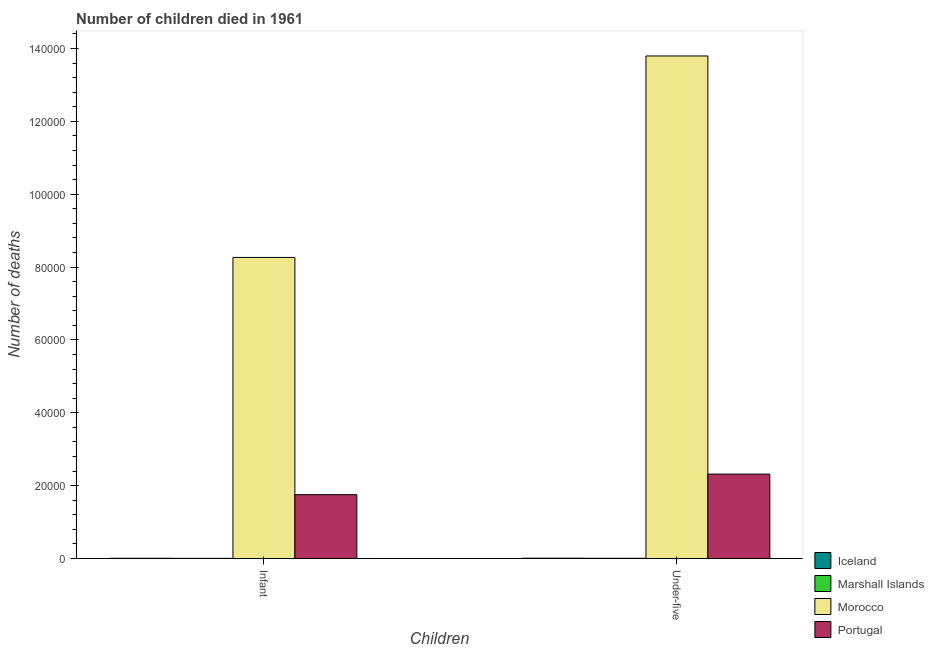How many different coloured bars are there?
Ensure brevity in your answer.  4. How many bars are there on the 2nd tick from the left?
Make the answer very short. 4. How many bars are there on the 2nd tick from the right?
Provide a short and direct response. 4. What is the label of the 2nd group of bars from the left?
Provide a succinct answer. Under-five. What is the number of under-five deaths in Morocco?
Your answer should be very brief. 1.38e+05. Across all countries, what is the maximum number of under-five deaths?
Make the answer very short. 1.38e+05. Across all countries, what is the minimum number of under-five deaths?
Keep it short and to the point. 79. In which country was the number of infant deaths maximum?
Your response must be concise. Morocco. In which country was the number of under-five deaths minimum?
Your response must be concise. Marshall Islands. What is the total number of under-five deaths in the graph?
Make the answer very short. 1.61e+05. What is the difference between the number of under-five deaths in Marshall Islands and that in Morocco?
Provide a succinct answer. -1.38e+05. What is the difference between the number of under-five deaths in Marshall Islands and the number of infant deaths in Iceland?
Your answer should be compact. -6. What is the average number of infant deaths per country?
Ensure brevity in your answer.  2.51e+04. What is the difference between the number of infant deaths and number of under-five deaths in Marshall Islands?
Your answer should be very brief. -23. In how many countries, is the number of infant deaths greater than 76000 ?
Your answer should be very brief. 1. What is the ratio of the number of under-five deaths in Morocco to that in Portugal?
Your answer should be very brief. 5.95. Is the number of infant deaths in Portugal less than that in Iceland?
Your response must be concise. No. In how many countries, is the number of infant deaths greater than the average number of infant deaths taken over all countries?
Keep it short and to the point. 1. What does the 3rd bar from the left in Infant represents?
Give a very brief answer. Morocco. How many countries are there in the graph?
Give a very brief answer. 4. What is the difference between two consecutive major ticks on the Y-axis?
Offer a terse response. 2.00e+04. Are the values on the major ticks of Y-axis written in scientific E-notation?
Make the answer very short. No. Does the graph contain any zero values?
Your answer should be very brief. No. Does the graph contain grids?
Your answer should be compact. No. Where does the legend appear in the graph?
Provide a succinct answer. Bottom right. What is the title of the graph?
Your answer should be very brief. Number of children died in 1961. What is the label or title of the X-axis?
Your answer should be very brief. Children. What is the label or title of the Y-axis?
Provide a succinct answer. Number of deaths. What is the Number of deaths of Iceland in Infant?
Your answer should be very brief. 85. What is the Number of deaths of Morocco in Infant?
Offer a very short reply. 8.27e+04. What is the Number of deaths of Portugal in Infant?
Offer a very short reply. 1.75e+04. What is the Number of deaths of Iceland in Under-five?
Your response must be concise. 104. What is the Number of deaths in Marshall Islands in Under-five?
Provide a short and direct response. 79. What is the Number of deaths of Morocco in Under-five?
Offer a terse response. 1.38e+05. What is the Number of deaths in Portugal in Under-five?
Provide a succinct answer. 2.32e+04. Across all Children, what is the maximum Number of deaths in Iceland?
Give a very brief answer. 104. Across all Children, what is the maximum Number of deaths of Marshall Islands?
Provide a succinct answer. 79. Across all Children, what is the maximum Number of deaths of Morocco?
Give a very brief answer. 1.38e+05. Across all Children, what is the maximum Number of deaths in Portugal?
Ensure brevity in your answer.  2.32e+04. Across all Children, what is the minimum Number of deaths of Iceland?
Keep it short and to the point. 85. Across all Children, what is the minimum Number of deaths in Marshall Islands?
Provide a succinct answer. 56. Across all Children, what is the minimum Number of deaths of Morocco?
Keep it short and to the point. 8.27e+04. Across all Children, what is the minimum Number of deaths in Portugal?
Keep it short and to the point. 1.75e+04. What is the total Number of deaths of Iceland in the graph?
Ensure brevity in your answer.  189. What is the total Number of deaths in Marshall Islands in the graph?
Your response must be concise. 135. What is the total Number of deaths of Morocco in the graph?
Offer a very short reply. 2.21e+05. What is the total Number of deaths in Portugal in the graph?
Offer a terse response. 4.07e+04. What is the difference between the Number of deaths of Iceland in Infant and that in Under-five?
Your answer should be compact. -19. What is the difference between the Number of deaths in Morocco in Infant and that in Under-five?
Keep it short and to the point. -5.53e+04. What is the difference between the Number of deaths of Portugal in Infant and that in Under-five?
Make the answer very short. -5643. What is the difference between the Number of deaths in Iceland in Infant and the Number of deaths in Morocco in Under-five?
Provide a succinct answer. -1.38e+05. What is the difference between the Number of deaths in Iceland in Infant and the Number of deaths in Portugal in Under-five?
Keep it short and to the point. -2.31e+04. What is the difference between the Number of deaths in Marshall Islands in Infant and the Number of deaths in Morocco in Under-five?
Make the answer very short. -1.38e+05. What is the difference between the Number of deaths in Marshall Islands in Infant and the Number of deaths in Portugal in Under-five?
Make the answer very short. -2.31e+04. What is the difference between the Number of deaths of Morocco in Infant and the Number of deaths of Portugal in Under-five?
Your answer should be compact. 5.95e+04. What is the average Number of deaths in Iceland per Children?
Give a very brief answer. 94.5. What is the average Number of deaths in Marshall Islands per Children?
Provide a succinct answer. 67.5. What is the average Number of deaths in Morocco per Children?
Ensure brevity in your answer.  1.10e+05. What is the average Number of deaths in Portugal per Children?
Provide a succinct answer. 2.04e+04. What is the difference between the Number of deaths in Iceland and Number of deaths in Marshall Islands in Infant?
Your response must be concise. 29. What is the difference between the Number of deaths in Iceland and Number of deaths in Morocco in Infant?
Your answer should be compact. -8.26e+04. What is the difference between the Number of deaths in Iceland and Number of deaths in Portugal in Infant?
Keep it short and to the point. -1.75e+04. What is the difference between the Number of deaths of Marshall Islands and Number of deaths of Morocco in Infant?
Your answer should be very brief. -8.26e+04. What is the difference between the Number of deaths of Marshall Islands and Number of deaths of Portugal in Infant?
Provide a succinct answer. -1.75e+04. What is the difference between the Number of deaths in Morocco and Number of deaths in Portugal in Infant?
Ensure brevity in your answer.  6.51e+04. What is the difference between the Number of deaths of Iceland and Number of deaths of Morocco in Under-five?
Provide a succinct answer. -1.38e+05. What is the difference between the Number of deaths in Iceland and Number of deaths in Portugal in Under-five?
Provide a short and direct response. -2.31e+04. What is the difference between the Number of deaths of Marshall Islands and Number of deaths of Morocco in Under-five?
Provide a short and direct response. -1.38e+05. What is the difference between the Number of deaths of Marshall Islands and Number of deaths of Portugal in Under-five?
Your response must be concise. -2.31e+04. What is the difference between the Number of deaths of Morocco and Number of deaths of Portugal in Under-five?
Your answer should be compact. 1.15e+05. What is the ratio of the Number of deaths in Iceland in Infant to that in Under-five?
Keep it short and to the point. 0.82. What is the ratio of the Number of deaths of Marshall Islands in Infant to that in Under-five?
Make the answer very short. 0.71. What is the ratio of the Number of deaths of Morocco in Infant to that in Under-five?
Your answer should be compact. 0.6. What is the ratio of the Number of deaths in Portugal in Infant to that in Under-five?
Keep it short and to the point. 0.76. What is the difference between the highest and the second highest Number of deaths in Iceland?
Offer a terse response. 19. What is the difference between the highest and the second highest Number of deaths of Marshall Islands?
Give a very brief answer. 23. What is the difference between the highest and the second highest Number of deaths of Morocco?
Provide a short and direct response. 5.53e+04. What is the difference between the highest and the second highest Number of deaths in Portugal?
Offer a terse response. 5643. What is the difference between the highest and the lowest Number of deaths in Marshall Islands?
Make the answer very short. 23. What is the difference between the highest and the lowest Number of deaths in Morocco?
Provide a short and direct response. 5.53e+04. What is the difference between the highest and the lowest Number of deaths of Portugal?
Offer a terse response. 5643. 